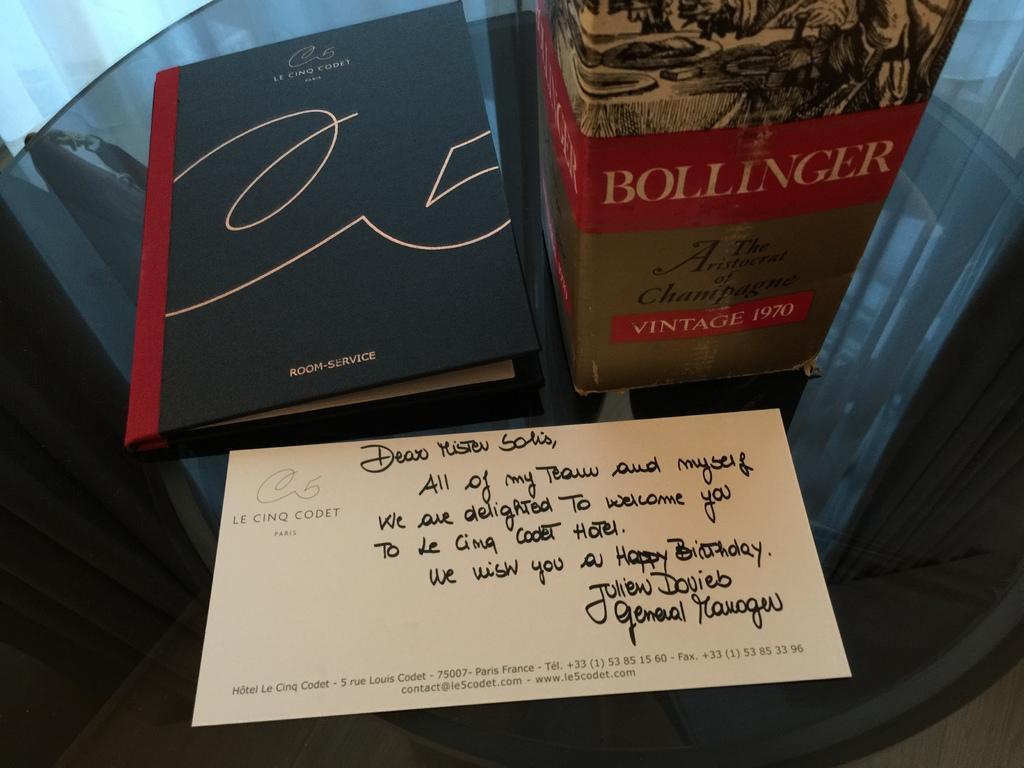Could you give a brief overview of what you see in this image? Here there is book, paper, box is present on the glass. 